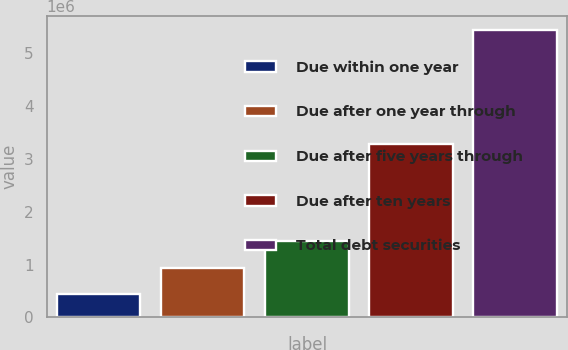<chart> <loc_0><loc_0><loc_500><loc_500><bar_chart><fcel>Due within one year<fcel>Due after one year through<fcel>Due after five years through<fcel>Due after ten years<fcel>Total debt securities<nl><fcel>438544<fcel>937526<fcel>1.43651e+06<fcel>3.28438e+06<fcel>5.42837e+06<nl></chart> 